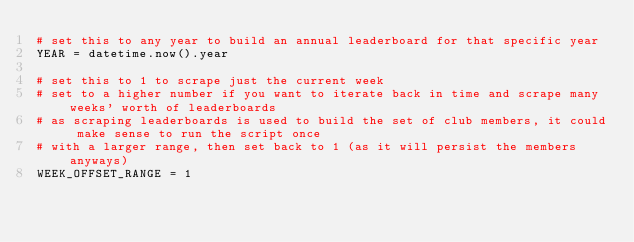Convert code to text. <code><loc_0><loc_0><loc_500><loc_500><_Python_># set this to any year to build an annual leaderboard for that specific year
YEAR = datetime.now().year

# set this to 1 to scrape just the current week
# set to a higher number if you want to iterate back in time and scrape many weeks' worth of leaderboards
# as scraping leaderboards is used to build the set of club members, it could make sense to run the script once
# with a larger range, then set back to 1 (as it will persist the members anyways)
WEEK_OFFSET_RANGE = 1
</code> 